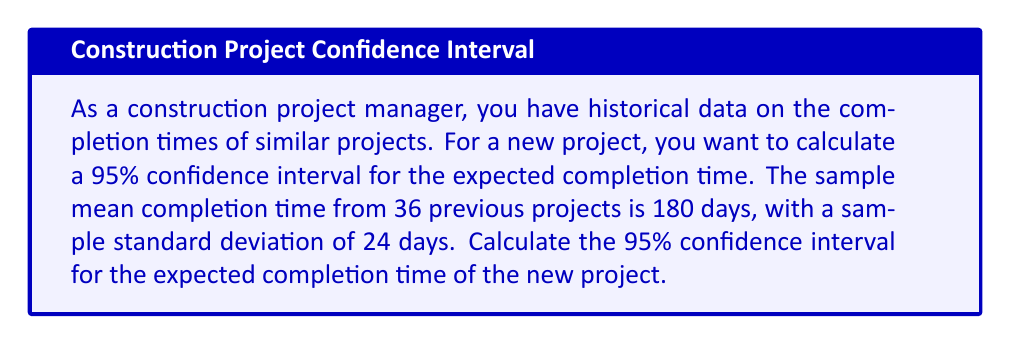Provide a solution to this math problem. To calculate the confidence interval, we'll use the formula:

$$ \text{CI} = \bar{x} \pm t_{\alpha/2} \cdot \frac{s}{\sqrt{n}} $$

Where:
- $\bar{x}$ is the sample mean (180 days)
- $s$ is the sample standard deviation (24 days)
- $n$ is the sample size (36 projects)
- $t_{\alpha/2}$ is the t-value for a 95% confidence interval with 35 degrees of freedom (n-1)

Steps:
1. Find $t_{\alpha/2}$:
   For a 95% CI with 35 df, $t_{\alpha/2} = 2.030$ (from t-distribution table)

2. Calculate the margin of error:
   $$ \text{ME} = t_{\alpha/2} \cdot \frac{s}{\sqrt{n}} = 2.030 \cdot \frac{24}{\sqrt{36}} = 2.030 \cdot 4 = 8.12 $$

3. Calculate the lower and upper bounds of the CI:
   $$ \text{Lower bound} = 180 - 8.12 = 171.88 $$
   $$ \text{Upper bound} = 180 + 8.12 = 188.12 $$

4. Round to the nearest whole number (as we're dealing with days):
   The 95% confidence interval is (172 days, 188 days).
Answer: (172 days, 188 days) 